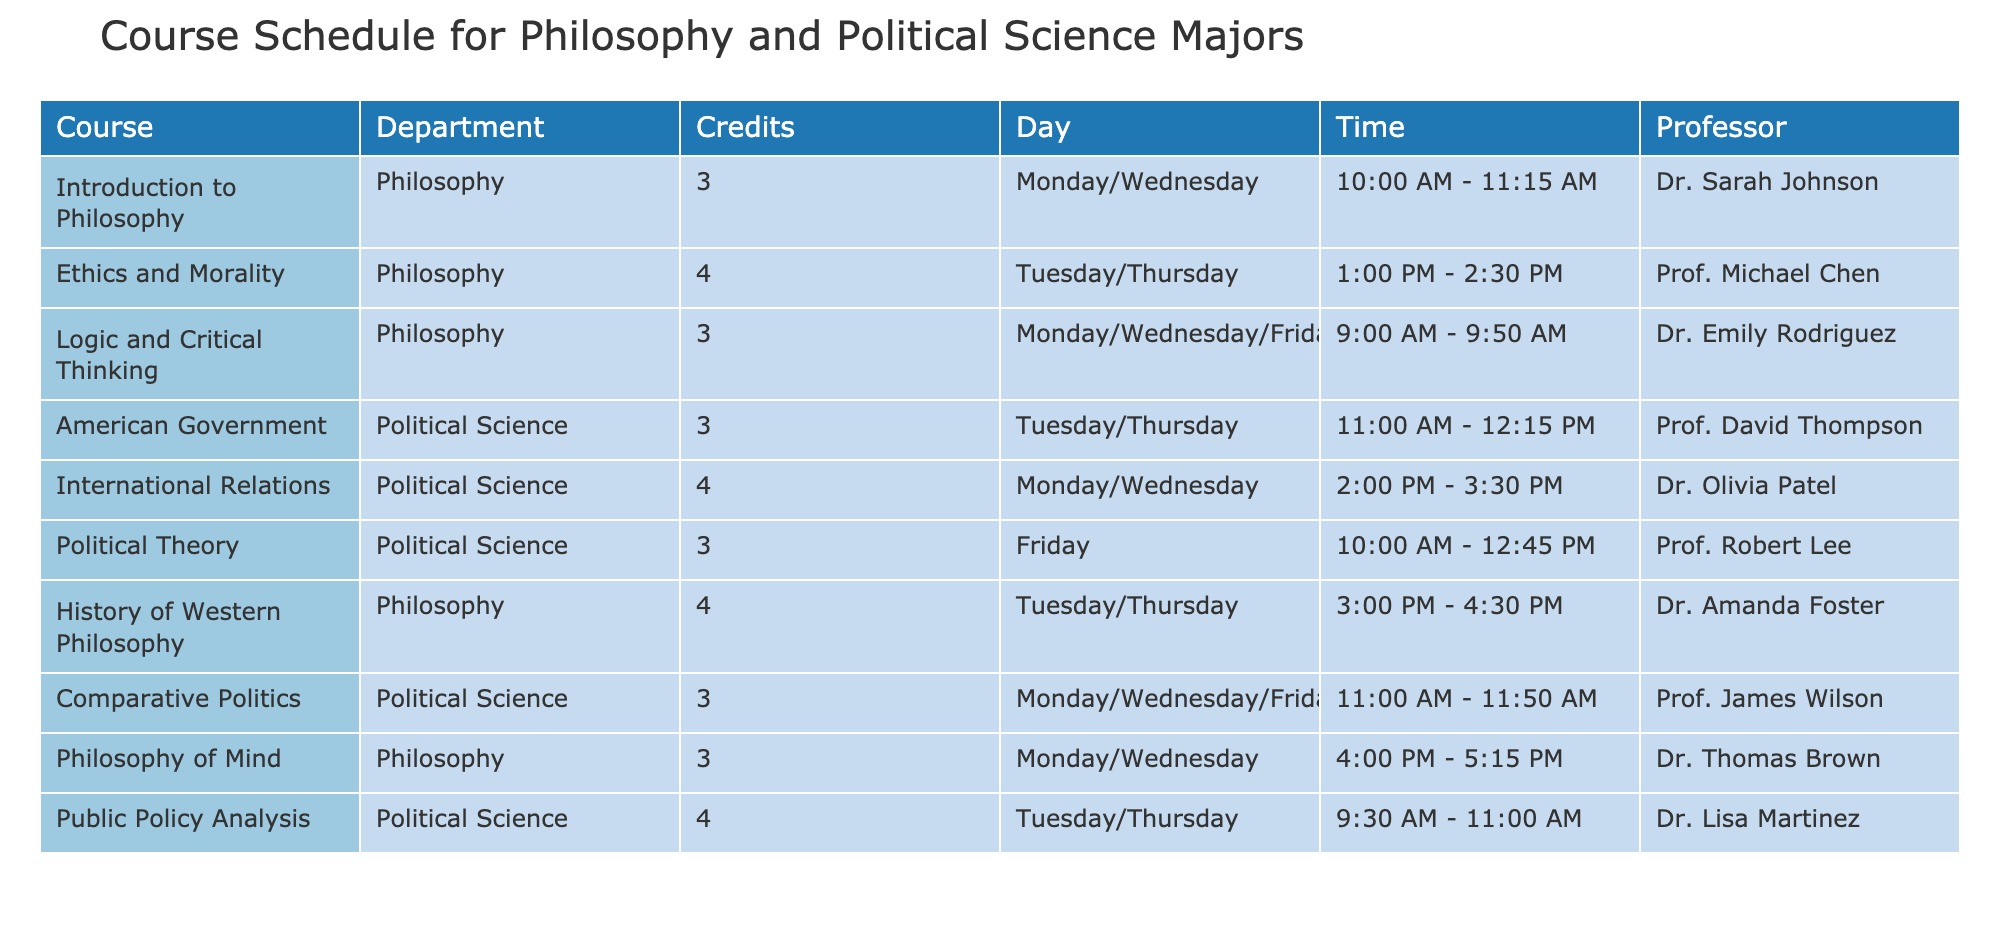What courses are offered by the Philosophy department? By looking at the 'Department' column and filtering for 'Philosophy', the courses listed are: Introduction to Philosophy, Ethics and Morality, Logic and Critical Thinking, History of Western Philosophy, and Philosophy of Mind.
Answer: Introduction to Philosophy, Ethics and Morality, Logic and Critical Thinking, History of Western Philosophy, Philosophy of Mind How many credits is the course Public Policy Analysis? The table states that the 'Credits' for the course 'Public Policy Analysis' is 4.
Answer: 4 Is there a course that overlaps with classes on Tuesday? The table lists 'American Government' and 'Public Policy Analysis' on Tuesday, so there are overlapping classes on that day.
Answer: Yes What is the maximum number of credits offered in a single course, and which course is it? The maximum credits listed in the table is 4, which is for the courses 'Ethics and Morality', 'International Relations', 'History of Western Philosophy', and 'Public Policy Analysis'.
Answer: 4 credits, Ethics and Morality / International Relations / History of Western Philosophy / Public Policy Analysis Which professor teaches Logic and Critical Thinking and what days is this course scheduled? The professor teaching 'Logic and Critical Thinking' is Dr. Emily Rodriguez, and the course is scheduled for Monday, Wednesday, and Friday.
Answer: Dr. Emily Rodriguez; Monday/Wednesday/Friday How many hours per week do students spend in class for the Philosophy major, considering all courses? Summing up the credits for Philosophy courses: 3 (Introduction to Philosophy) + 4 (Ethics and Morality) + 3 (Logic and Critical Thinking) + 4 (History of Western Philosophy) + 3 (Philosophy of Mind) = 17 credits. Assuming 1 credit = 1 hour per week in class, students spend 17 hours in class for Philosophy.
Answer: 17 hours Which course occurs first in the weekly schedule: American Government or International Relations? By comparing the schedule, 'American Government' occurs on Tuesday/Thursday at 11:00 AM, while 'International Relations' is on Monday/Wednesday at 2:00 PM. Therefore, 'American Government' occurs first in the week.
Answer: American Government How many courses are scheduled on Friday, and what are they? Reviewing the table, only one course is scheduled on Friday: 'Political Theory'. Thus, there is a total of one course on this day.
Answer: 1 course: Political Theory 